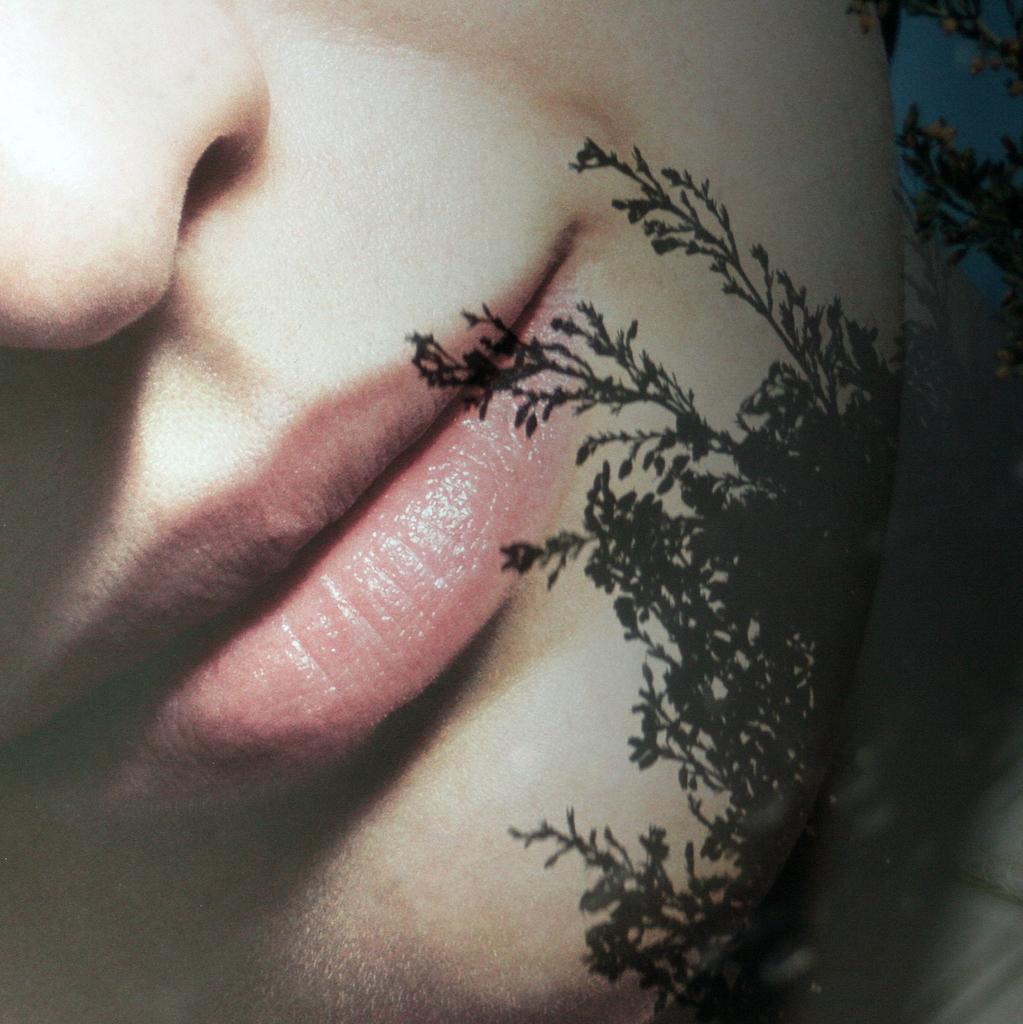How would you summarize this image in a sentence or two? This is an edited image, we can see the head of a person. 